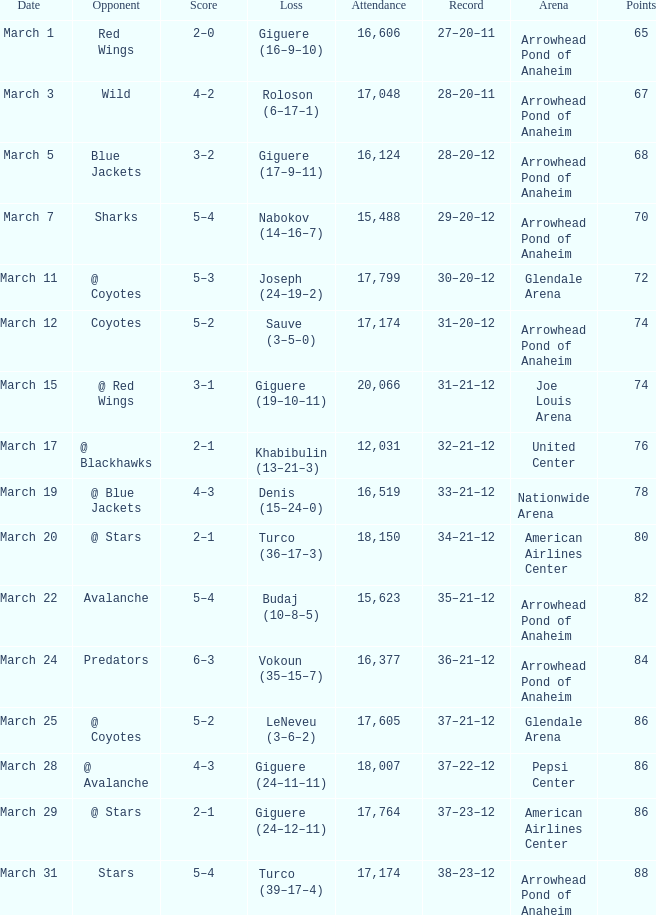What is the Record of the game with an Attendance of more than 16,124 and a Score of 6–3? 36–21–12. 